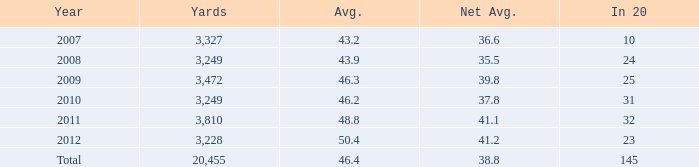Could you parse the entire table as a dict? {'header': ['Year', 'Yards', 'Avg.', 'Net Avg.', 'In 20'], 'rows': [['2007', '3,327', '43.2', '36.6', '10'], ['2008', '3,249', '43.9', '35.5', '24'], ['2009', '3,472', '46.3', '39.8', '25'], ['2010', '3,249', '46.2', '37.8', '31'], ['2011', '3,810', '48.8', '41.1', '32'], ['2012', '3,228', '50.4', '41.2', '23'], ['Total', '20,455', '46.4', '38.8', '145']]} If 32 is given as 20 units, how many yards does it correspond to? 1.0. 